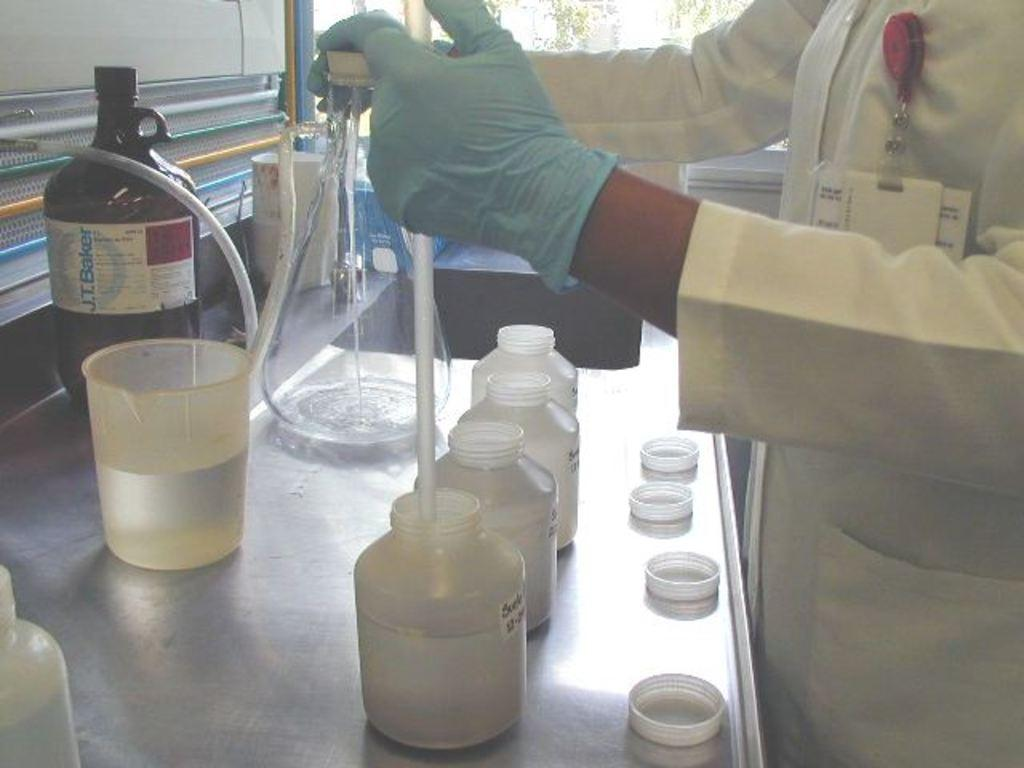<image>
Share a concise interpretation of the image provided. Someone working in a lab near a bottle of a chemical by J. T. Baker 